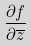Convert formula to latex. <formula><loc_0><loc_0><loc_500><loc_500>\frac { \partial f } { \partial \overline { z } }</formula> 